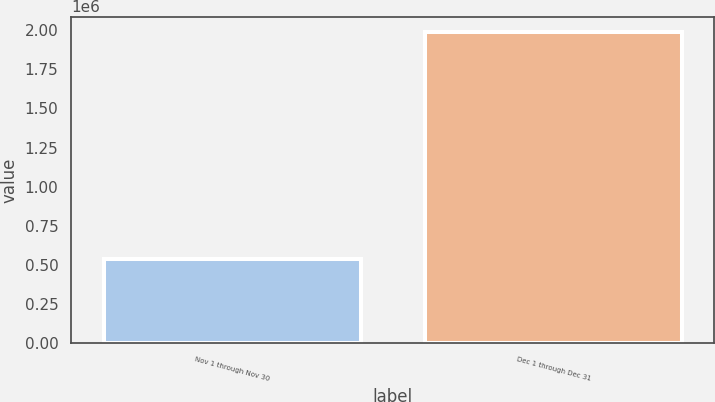Convert chart to OTSL. <chart><loc_0><loc_0><loc_500><loc_500><bar_chart><fcel>Nov 1 through Nov 30<fcel>Dec 1 through Dec 31<nl><fcel>540294<fcel>1.98608e+06<nl></chart> 